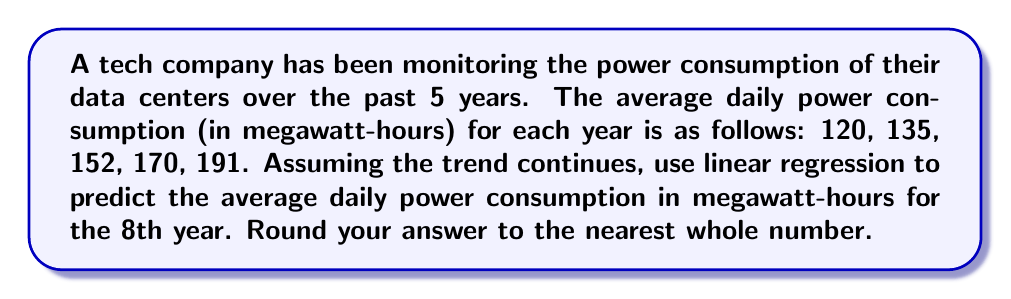Show me your answer to this math problem. Let's approach this step-by-step using linear regression:

1) First, let's set up our data points:
   x (year): 1, 2, 3, 4, 5
   y (consumption): 120, 135, 152, 170, 191

2) We need to calculate the following sums:
   $\sum x = 1 + 2 + 3 + 4 + 5 = 15$
   $\sum y = 120 + 135 + 152 + 170 + 191 = 768$
   $\sum xy = (1)(120) + (2)(135) + (3)(152) + (4)(170) + (5)(191) = 2441$
   $\sum x^2 = 1^2 + 2^2 + 3^2 + 4^2 + 5^2 = 55$

3) The linear regression equation is $y = mx + b$, where:

   $m = \frac{n\sum xy - \sum x \sum y}{n\sum x^2 - (\sum x)^2}$

   $b = \frac{\sum y - m\sum x}{n}$

   where n is the number of data points (5 in this case).

4) Let's calculate m:
   $$m = \frac{5(2441) - (15)(768)}{5(55) - (15)^2} = \frac{12205 - 11520}{275 - 225} = \frac{685}{50} = 13.7$$

5) Now let's calculate b:
   $$b = \frac{768 - 13.7(15)}{5} = \frac{768 - 205.5}{5} = 112.5$$

6) Our linear regression equation is therefore:
   $y = 13.7x + 112.5$

7) To predict the 8th year, we substitute x = 8:
   $y = 13.7(8) + 112.5 = 109.6 + 112.5 = 222.1$

8) Rounding to the nearest whole number, we get 222.
Answer: 222 megawatt-hours 